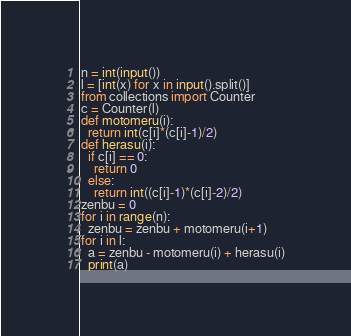<code> <loc_0><loc_0><loc_500><loc_500><_Python_>n = int(input())
l = [int(x) for x in input().split()]
from collections import Counter
c = Counter(l)
def motomeru(i):
  return int(c[i]*(c[i]-1)/2)
def herasu(i):
  if c[i] == 0:
    return 0
  else:
    return int((c[i]-1)*(c[i]-2)/2)
zenbu = 0
for i in range(n):
  zenbu = zenbu + motomeru(i+1)
for i in l:
  a = zenbu - motomeru(i) + herasu(i)
  print(a)</code> 